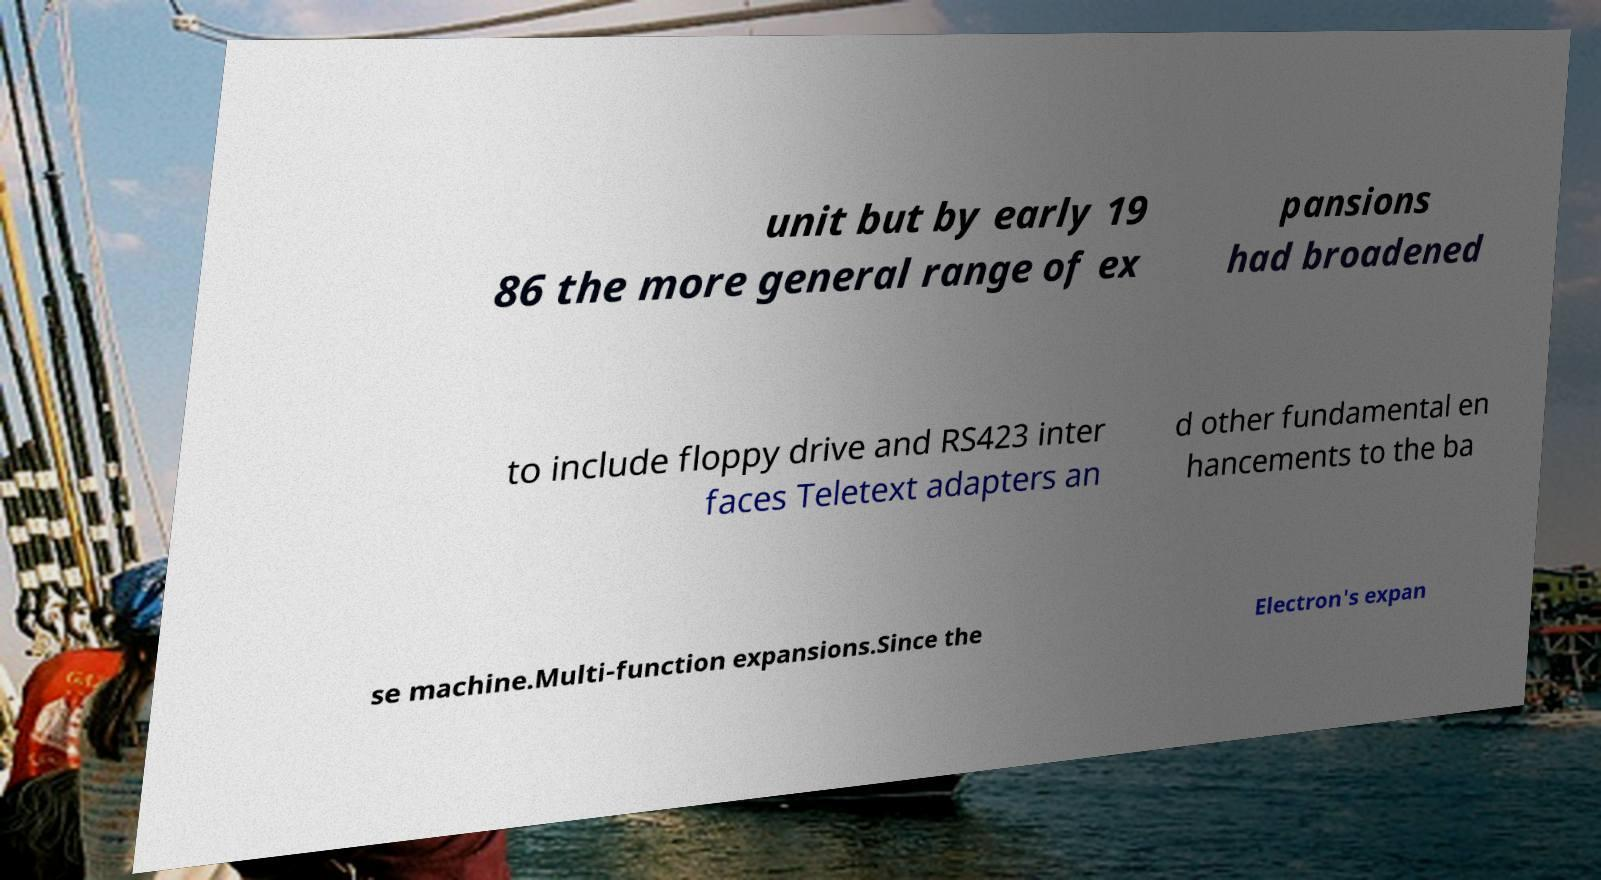Please read and relay the text visible in this image. What does it say? unit but by early 19 86 the more general range of ex pansions had broadened to include floppy drive and RS423 inter faces Teletext adapters an d other fundamental en hancements to the ba se machine.Multi-function expansions.Since the Electron's expan 